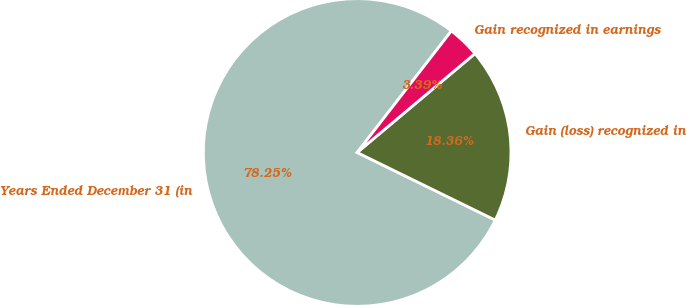Convert chart to OTSL. <chart><loc_0><loc_0><loc_500><loc_500><pie_chart><fcel>Years Ended December 31 (in<fcel>Gain (loss) recognized in<fcel>Gain recognized in earnings<nl><fcel>78.25%<fcel>18.36%<fcel>3.39%<nl></chart> 